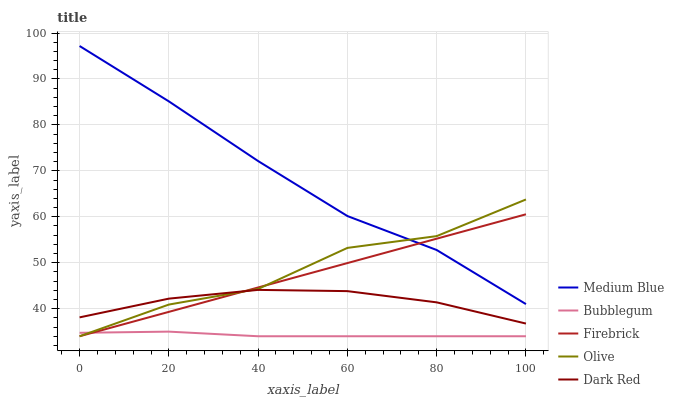Does Bubblegum have the minimum area under the curve?
Answer yes or no. Yes. Does Medium Blue have the maximum area under the curve?
Answer yes or no. Yes. Does Dark Red have the minimum area under the curve?
Answer yes or no. No. Does Dark Red have the maximum area under the curve?
Answer yes or no. No. Is Firebrick the smoothest?
Answer yes or no. Yes. Is Olive the roughest?
Answer yes or no. Yes. Is Dark Red the smoothest?
Answer yes or no. No. Is Dark Red the roughest?
Answer yes or no. No. Does Olive have the lowest value?
Answer yes or no. Yes. Does Dark Red have the lowest value?
Answer yes or no. No. Does Medium Blue have the highest value?
Answer yes or no. Yes. Does Dark Red have the highest value?
Answer yes or no. No. Is Bubblegum less than Medium Blue?
Answer yes or no. Yes. Is Medium Blue greater than Dark Red?
Answer yes or no. Yes. Does Bubblegum intersect Firebrick?
Answer yes or no. Yes. Is Bubblegum less than Firebrick?
Answer yes or no. No. Is Bubblegum greater than Firebrick?
Answer yes or no. No. Does Bubblegum intersect Medium Blue?
Answer yes or no. No. 